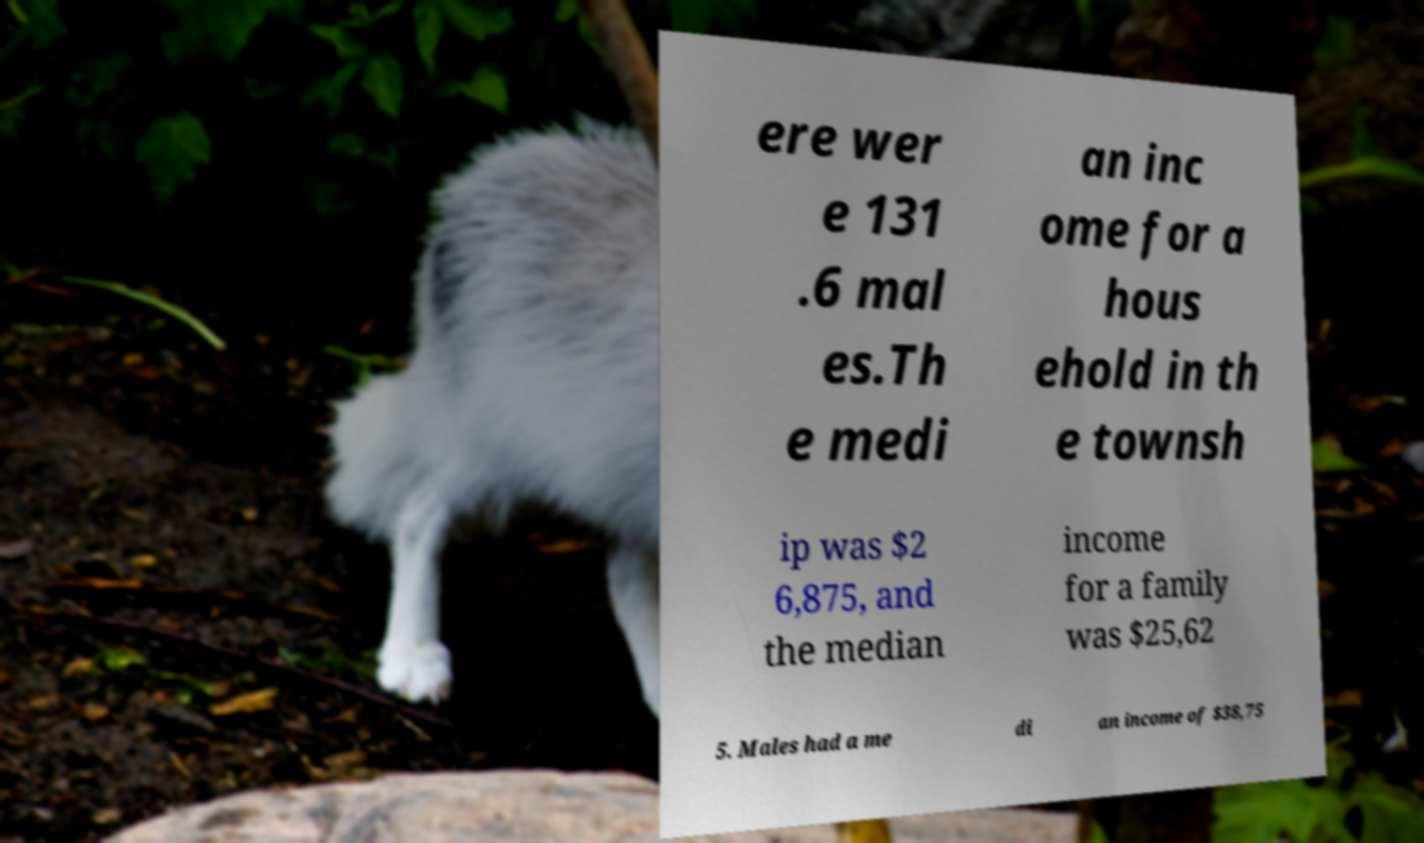For documentation purposes, I need the text within this image transcribed. Could you provide that? ere wer e 131 .6 mal es.Th e medi an inc ome for a hous ehold in th e townsh ip was $2 6,875, and the median income for a family was $25,62 5. Males had a me di an income of $38,75 